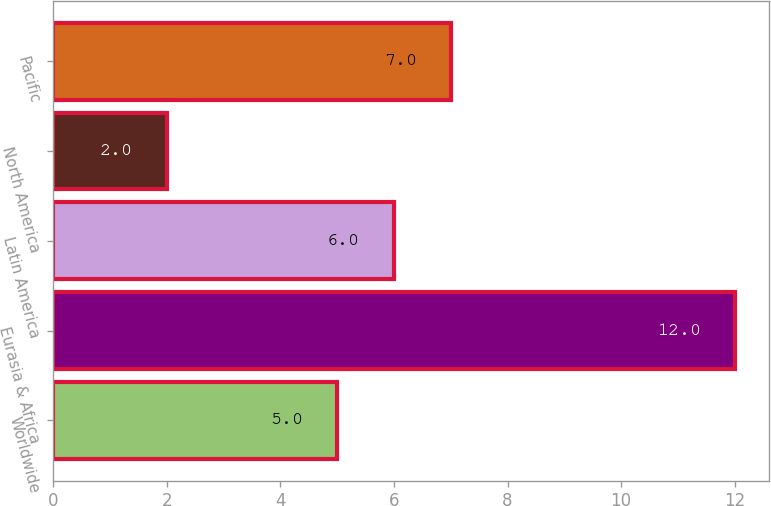Convert chart to OTSL. <chart><loc_0><loc_0><loc_500><loc_500><bar_chart><fcel>Worldwide<fcel>Eurasia & Africa<fcel>Latin America<fcel>North America<fcel>Pacific<nl><fcel>5<fcel>12<fcel>6<fcel>2<fcel>7<nl></chart> 